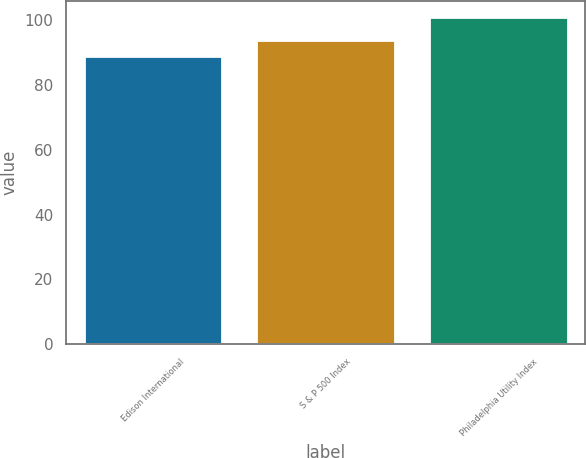Convert chart. <chart><loc_0><loc_0><loc_500><loc_500><bar_chart><fcel>Edison International<fcel>S & P 500 Index<fcel>Philadelphia Utility Index<nl><fcel>89<fcel>94<fcel>101<nl></chart> 